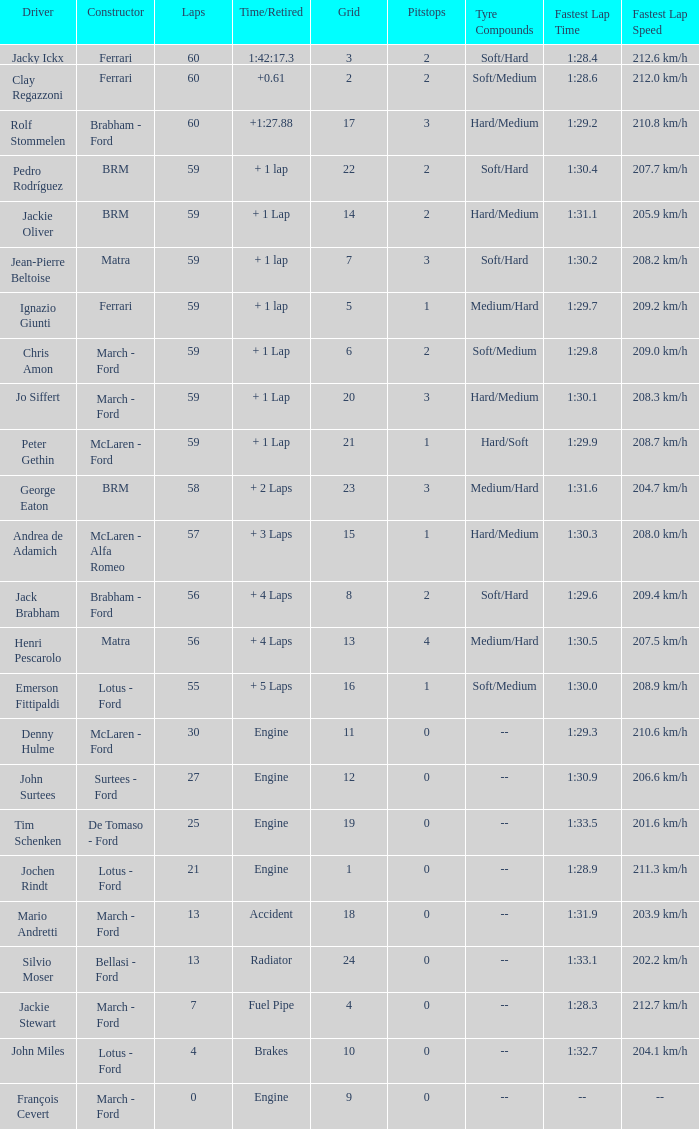I want the driver for grid of 9 François Cevert. 